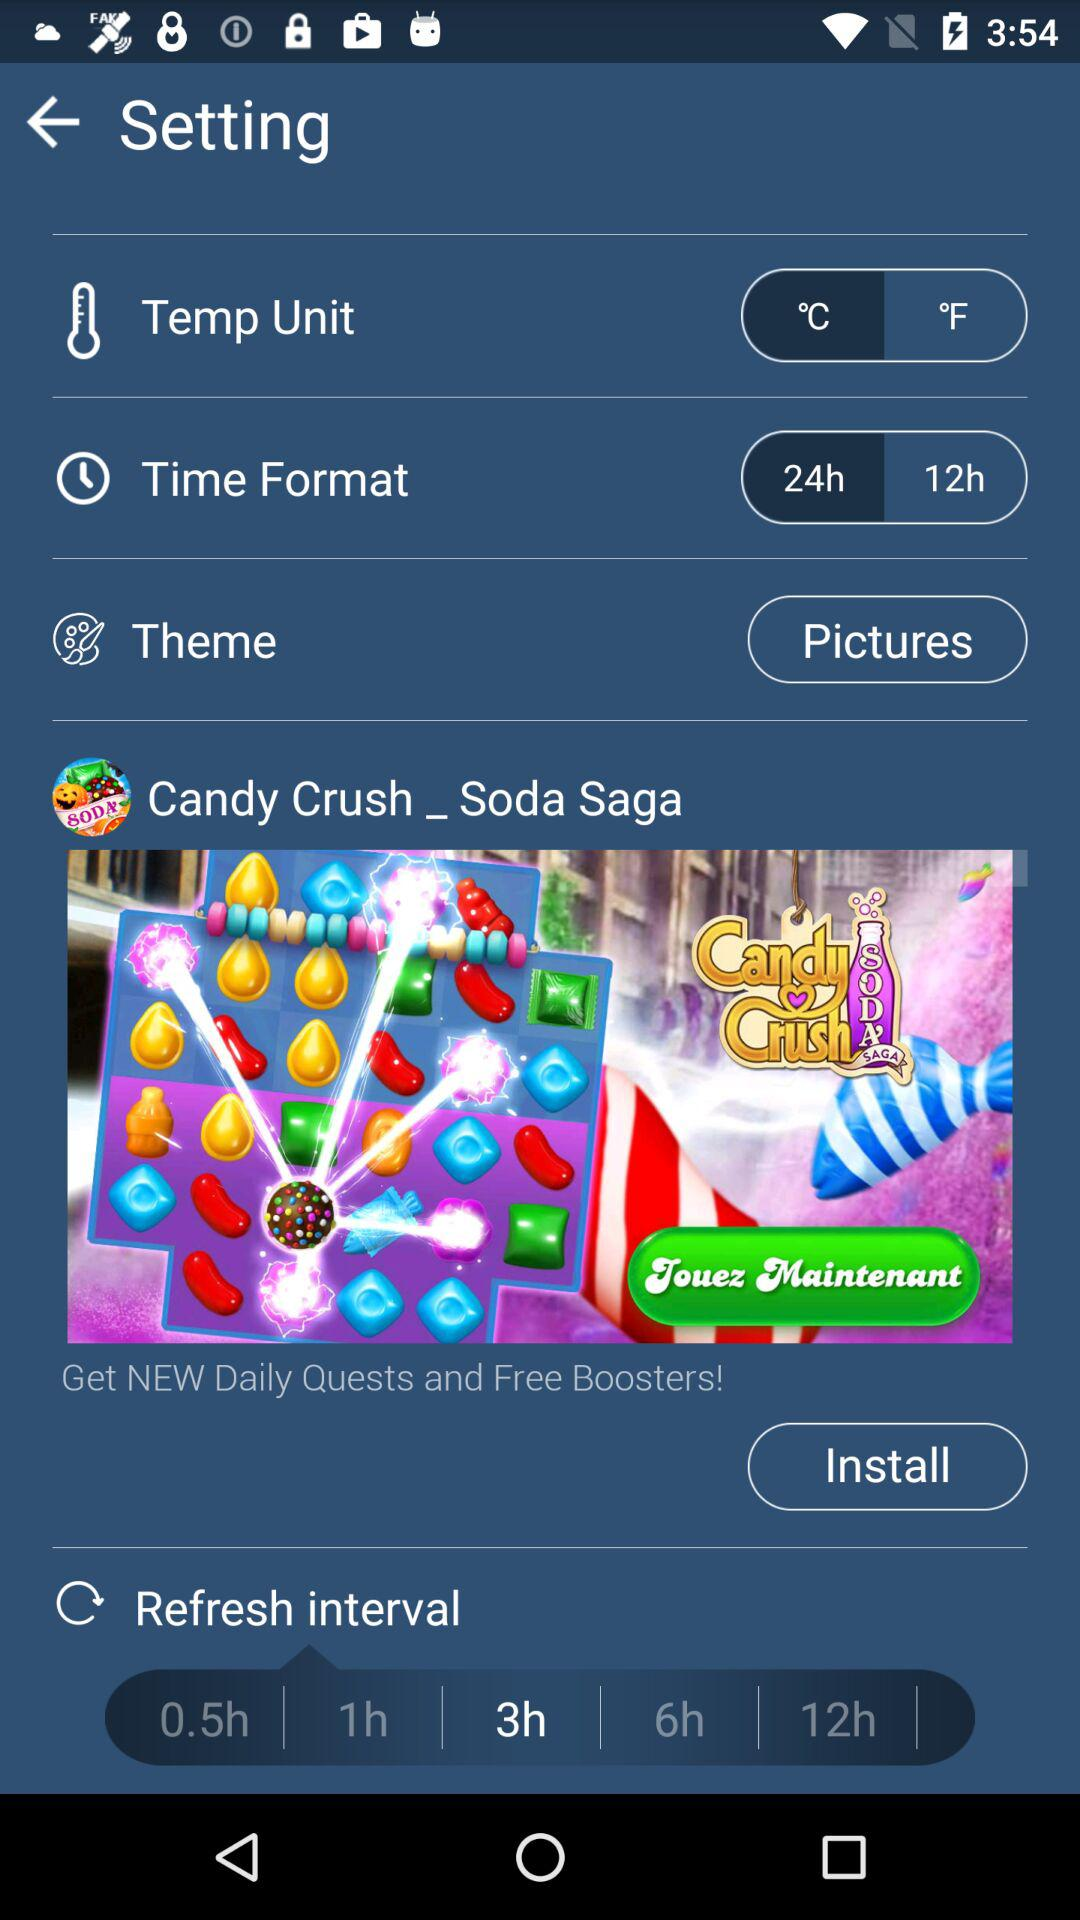What is the "Time Format"? The "Time Format" is 24 h. 